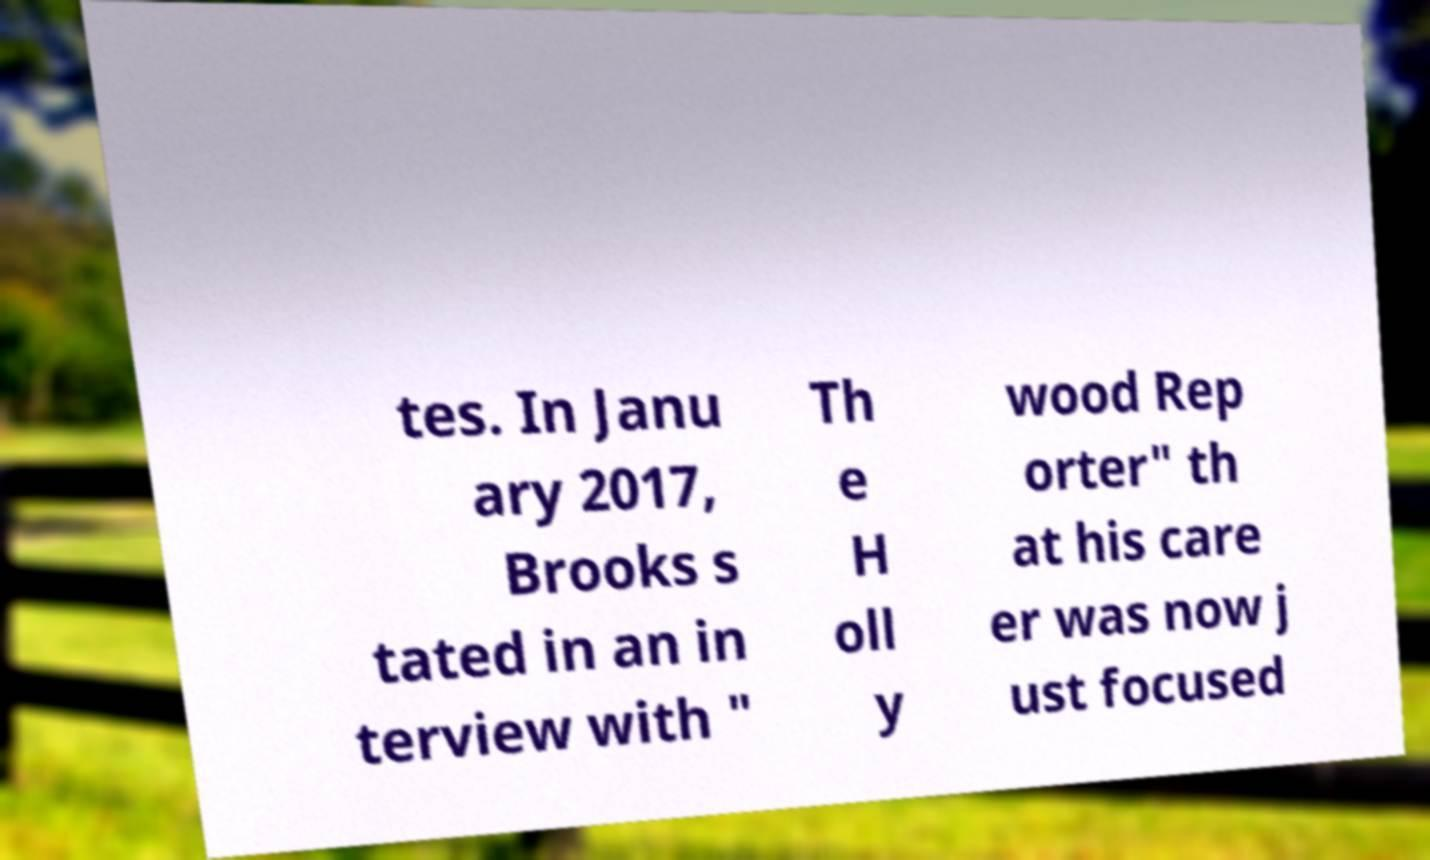Please read and relay the text visible in this image. What does it say? tes. In Janu ary 2017, Brooks s tated in an in terview with " Th e H oll y wood Rep orter" th at his care er was now j ust focused 